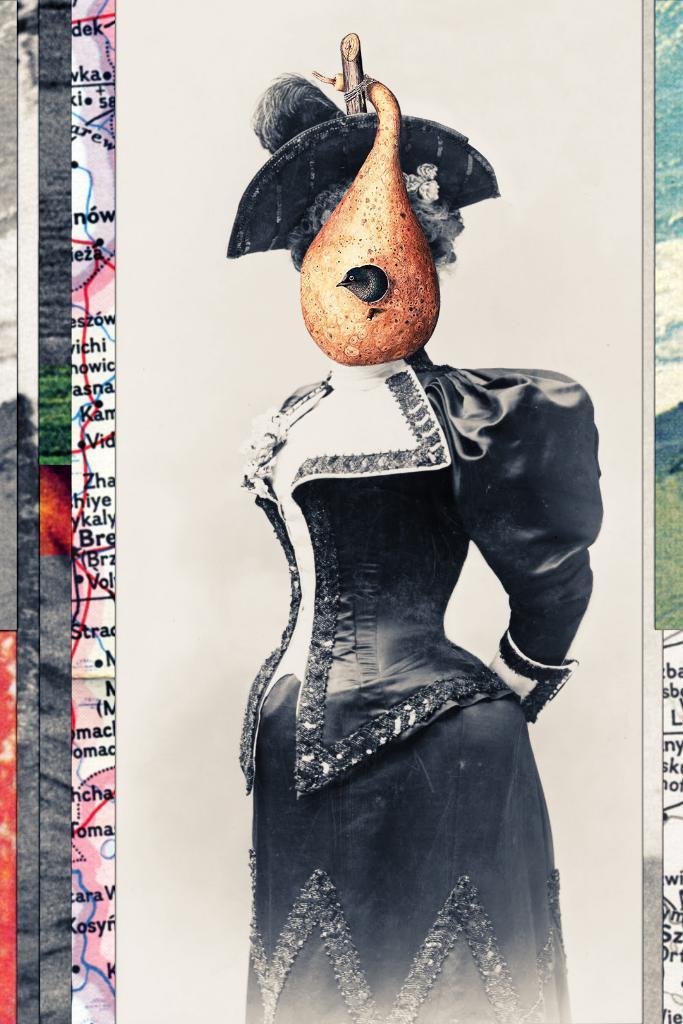In one or two sentences, can you explain what this image depicts? In this image I can see a person's wall painting, grass and the sky. This image is taken during a day. 